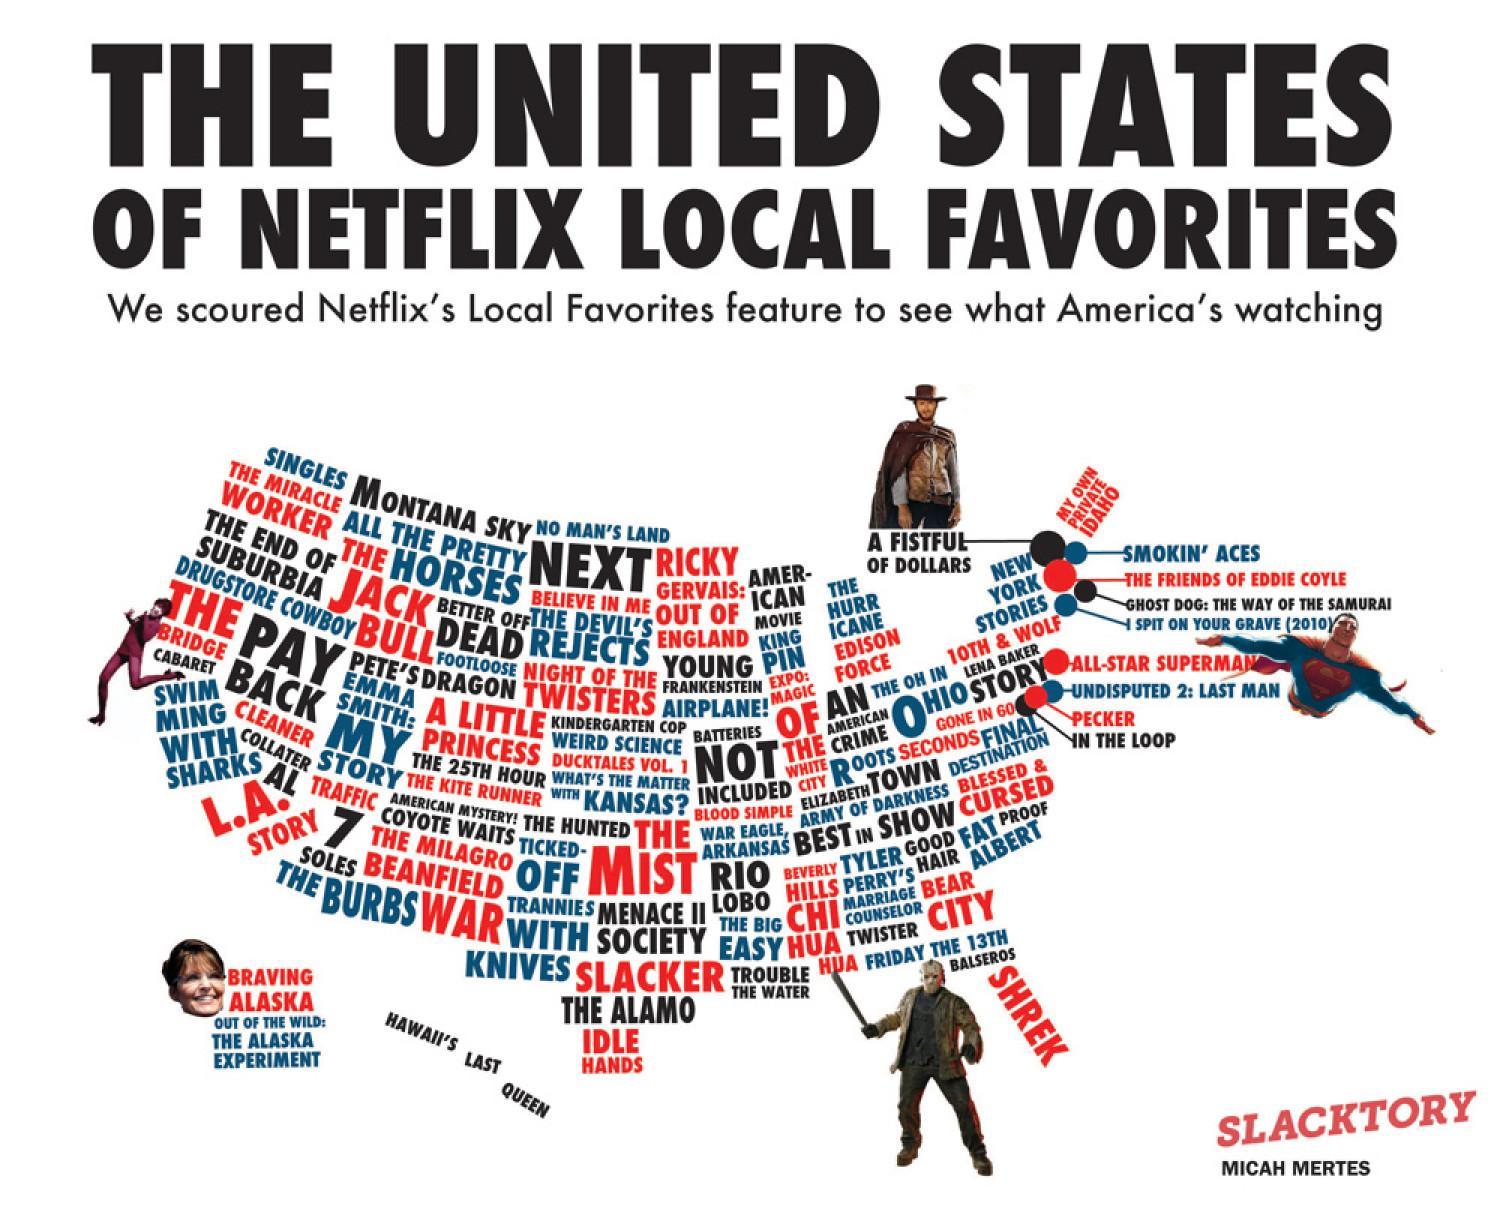Draw attention to some important aspects in this diagram. SHREK is a green ogre character in various media. The text color for SHREK is white, black, and red. The color red is associated with SHREK. The year written next to Superman is 2010. 